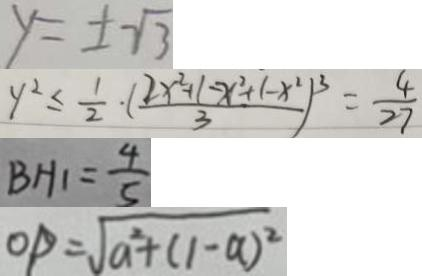<formula> <loc_0><loc_0><loc_500><loc_500>y = \pm \sqrt { 3 } 
 y ^ { 2 } \leq \frac { 1 } { 2 } \cdot ( \frac { 2 x ^ { 2 } + 1 - x ^ { 2 } + ( - x ^ { 2 } ) } { 3 } ) ^ { 3 } = \frac { 4 } { 2 7 } 
 B H _ { 1 } = \frac { 4 } { 5 } 
 O P = \sqrt { a ^ { 2 } + ( 1 - a ) ^ { 2 } }</formula> 